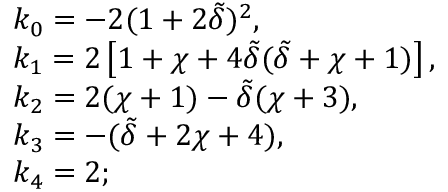Convert formula to latex. <formula><loc_0><loc_0><loc_500><loc_500>\begin{array} { r l } & { k _ { 0 } = - 2 ( 1 + 2 \tilde { \delta } ) ^ { 2 } , } \\ & { k _ { 1 } = 2 \left [ 1 + \chi + 4 \tilde { \delta } ( \tilde { \delta } + \chi + 1 ) \right ] , } \\ & { k _ { 2 } = 2 ( \chi + 1 ) - \tilde { \delta } ( \chi + 3 ) , } \\ & { k _ { 3 } = - ( \tilde { \delta } + 2 \chi + 4 ) , } \\ & { k _ { 4 } = 2 ; } \end{array}</formula> 